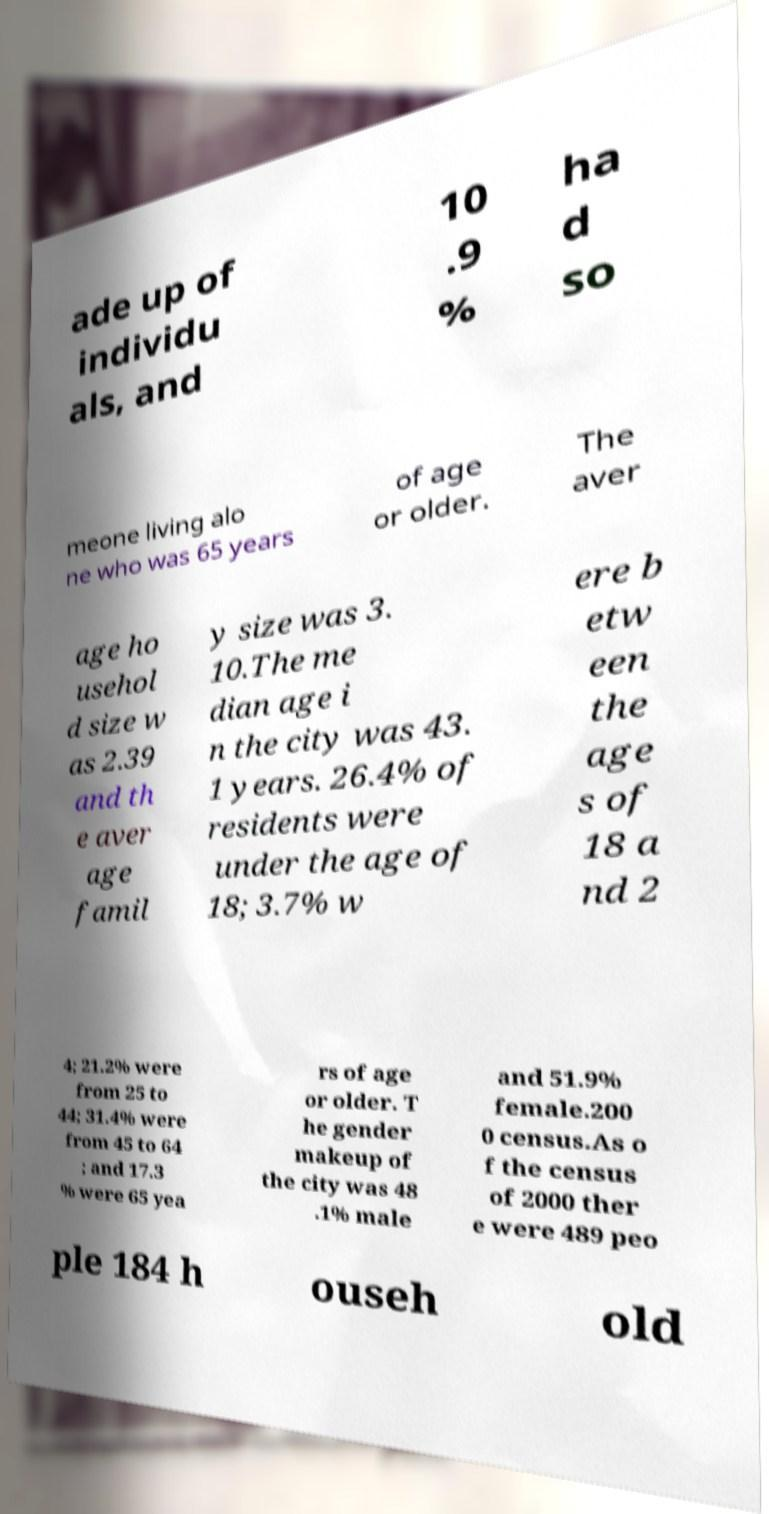I need the written content from this picture converted into text. Can you do that? ade up of individu als, and 10 .9 % ha d so meone living alo ne who was 65 years of age or older. The aver age ho usehol d size w as 2.39 and th e aver age famil y size was 3. 10.The me dian age i n the city was 43. 1 years. 26.4% of residents were under the age of 18; 3.7% w ere b etw een the age s of 18 a nd 2 4; 21.2% were from 25 to 44; 31.4% were from 45 to 64 ; and 17.3 % were 65 yea rs of age or older. T he gender makeup of the city was 48 .1% male and 51.9% female.200 0 census.As o f the census of 2000 ther e were 489 peo ple 184 h ouseh old 